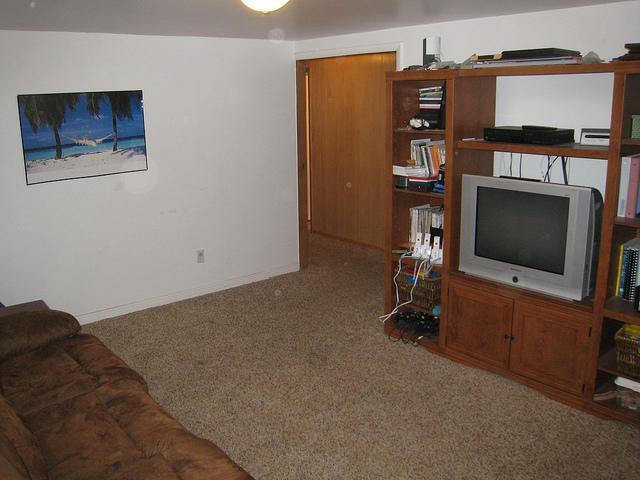How many pictures are on the wall?
Give a very brief answer. 1. 